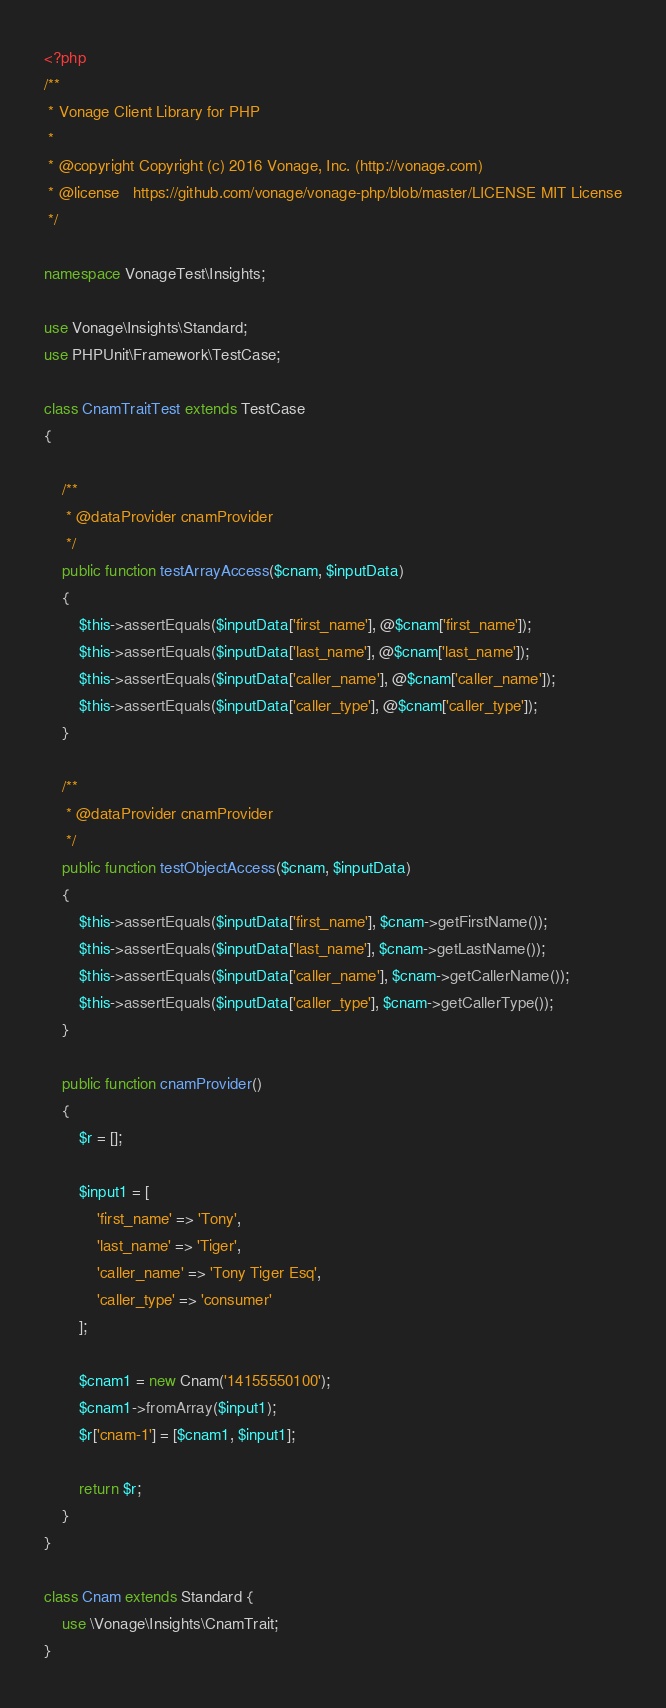Convert code to text. <code><loc_0><loc_0><loc_500><loc_500><_PHP_><?php
/**
 * Vonage Client Library for PHP
 *
 * @copyright Copyright (c) 2016 Vonage, Inc. (http://vonage.com)
 * @license   https://github.com/vonage/vonage-php/blob/master/LICENSE MIT License
 */

namespace VonageTest\Insights;

use Vonage\Insights\Standard;
use PHPUnit\Framework\TestCase;

class CnamTraitTest extends TestCase
{

    /**
     * @dataProvider cnamProvider
     */
    public function testArrayAccess($cnam, $inputData)
    {
        $this->assertEquals($inputData['first_name'], @$cnam['first_name']);
        $this->assertEquals($inputData['last_name'], @$cnam['last_name']);
        $this->assertEquals($inputData['caller_name'], @$cnam['caller_name']);
        $this->assertEquals($inputData['caller_type'], @$cnam['caller_type']);
    }

    /**
     * @dataProvider cnamProvider
     */
    public function testObjectAccess($cnam, $inputData)
    {
        $this->assertEquals($inputData['first_name'], $cnam->getFirstName());
        $this->assertEquals($inputData['last_name'], $cnam->getLastName());
        $this->assertEquals($inputData['caller_name'], $cnam->getCallerName());
        $this->assertEquals($inputData['caller_type'], $cnam->getCallerType());
    }

    public function cnamProvider()
    {
        $r = [];

        $input1 = [
            'first_name' => 'Tony',
            'last_name' => 'Tiger',
            'caller_name' => 'Tony Tiger Esq',
            'caller_type' => 'consumer'
        ];

        $cnam1 = new Cnam('14155550100');
        $cnam1->fromArray($input1);
        $r['cnam-1'] = [$cnam1, $input1];

        return $r;
    }
}

class Cnam extends Standard {
    use \Vonage\Insights\CnamTrait;
}
</code> 